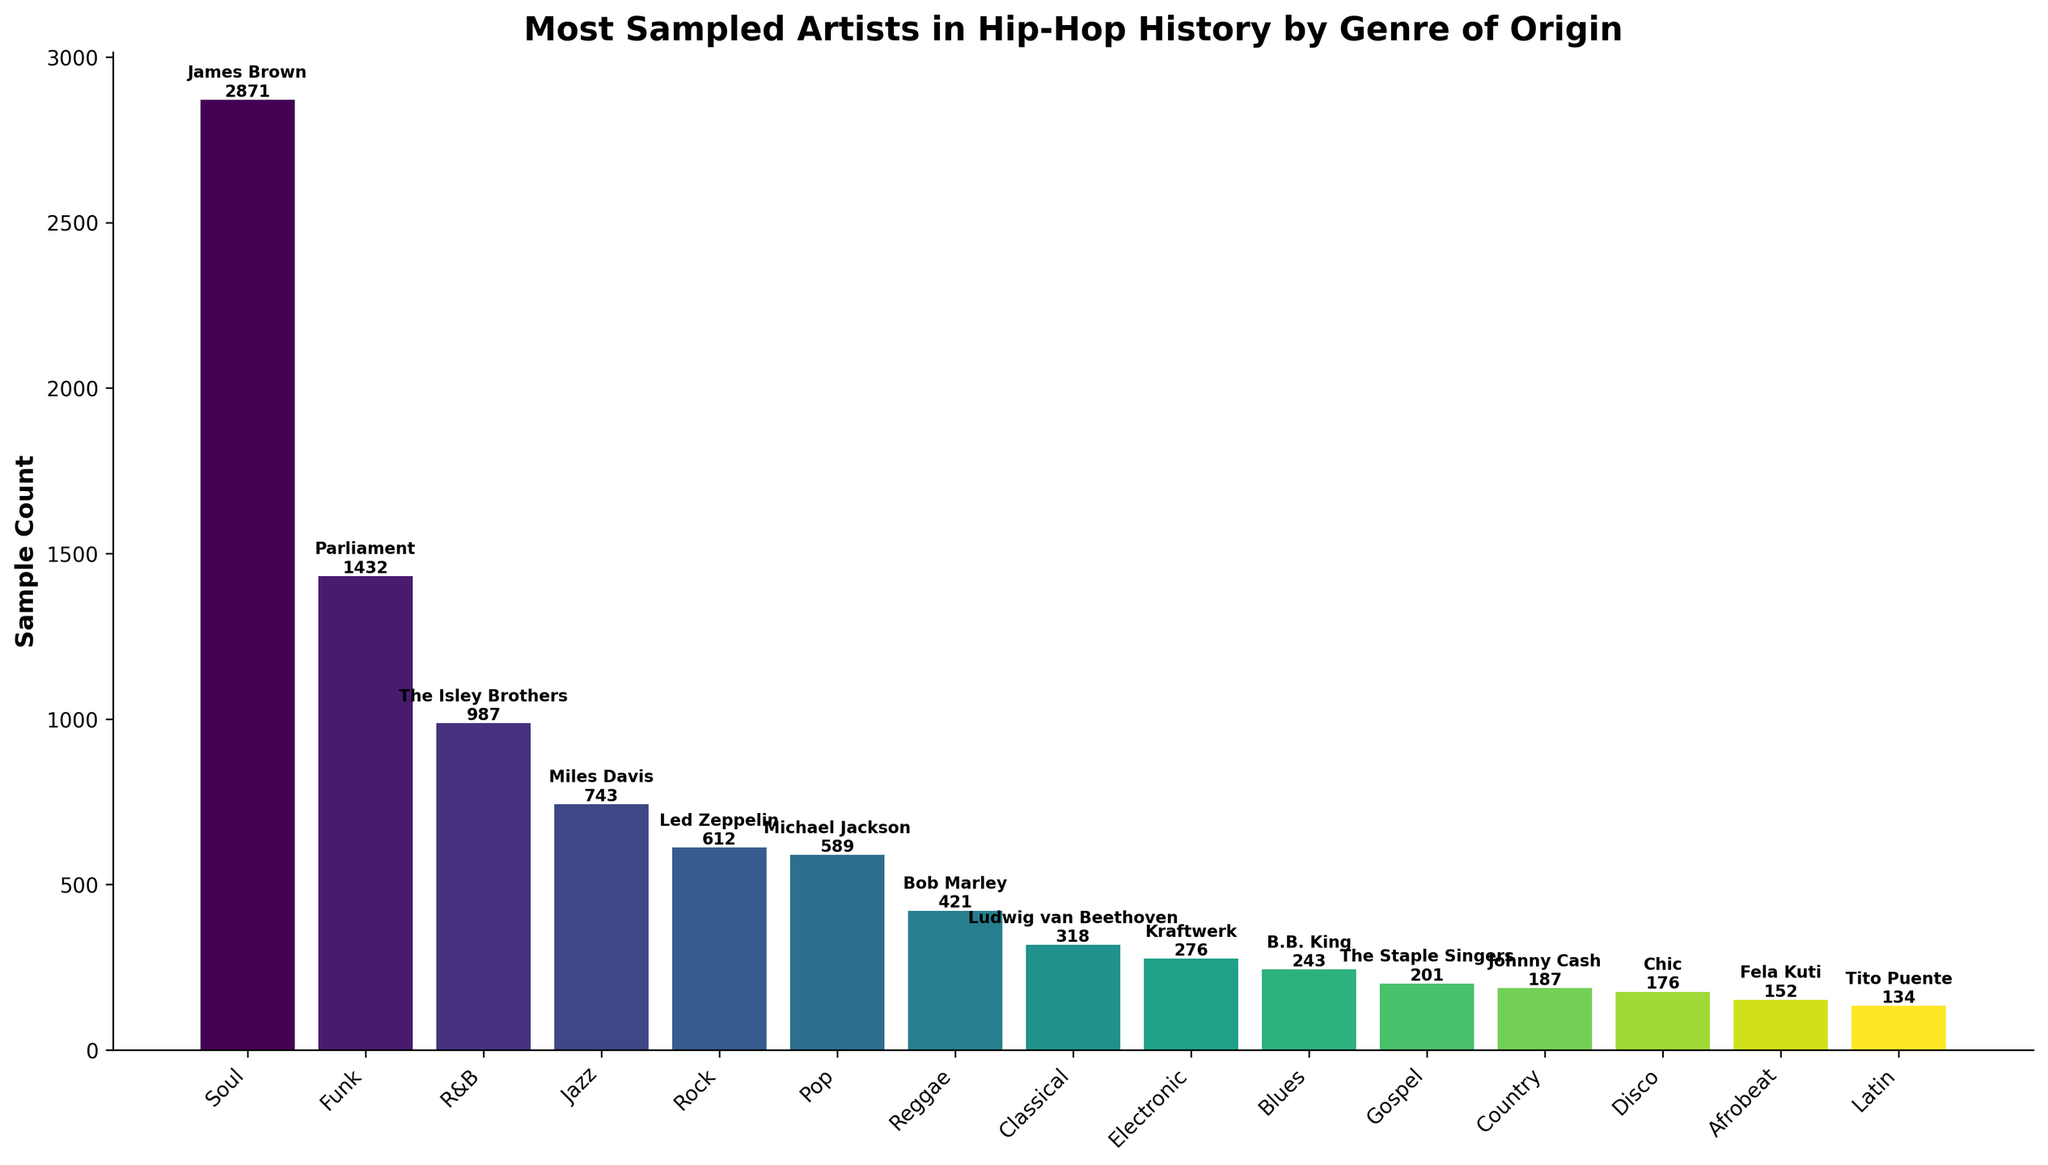Which genre's artist has the highest sample count? James Brown in the Soul genre has the highest sample count of 2871. This can be determined by looking at the tallest bar, which represents the artist with the highest sample count and is specifically labeled with James Brown and the number 2871.
Answer: Soul Which artist from the Jazz genre has the most samples? By identifying the genre Jazz on the x-axis and looking at the corresponding bar, we see that it is labeled with Miles Davis and a sample count of 743.
Answer: Miles Davis What is the difference in sample count between the most sampled Pop and Reggae artists? Michael Jackson (Pop) has 589 samples and Bob Marley (Reggae) has 421 samples. The difference between them is 589 - 421 = 168.
Answer: 168 Which artist is more sampled: The Isley Brothers or Led Zeppelin? By comparing the heights of the bars and their respective labels, we can see that The Isley Brothers have 987 samples while Led Zeppelin has 612 samples. Therefore, The Isley Brothers are more sampled.
Answer: The Isley Brothers What is the total sample count of artists from Funk and Jazz genres combined? Parliament from Funk has 1432 samples and Miles Davis from Jazz has 743 samples. Their combined total is 1432 + 743 = 2175.
Answer: 2175 Who is the most sampled artist from the Electronic genre? Looking at the bar associated with the Electronic genre, it is labeled with Kraftwerk and a sample count of 276.
Answer: Kraftwerk Which artist has the smallest sample count, and what is their genre? By identifying the shortest bar, we see that it is labeled with Tito Puente, having a sample count of 134 and the genre is Latin.
Answer: Tito Puente, Latin Rank the artists from the Country and Blues genres based on their sample counts. Johnny Cash (Country) has 187 samples, and B.B. King (Blues) has 243 samples. Therefore, B.B. King is ranked higher.
Answer: B.B. King, Johnny Cash How many more samples does James Brown have compared to Kraftwerk? James Brown has 2871 samples and Kraftwerk has 276 samples. The difference is 2871 - 276 = 2595.
Answer: 2595 Calculate the average sample count of artists from the genres Rock, Reggae, and Gospel. The respective sample counts are: Led Zeppelin (Rock) - 612, Bob Marley (Reggae) - 421, The Staple Singers (Gospel) - 201. Their total is 612 + 421 + 201 = 1234. The average is 1234 / 3 = 411.33.
Answer: 411.33 